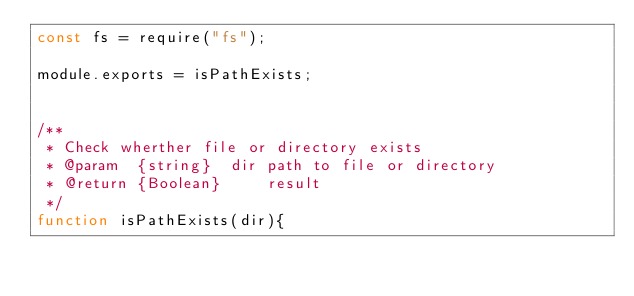Convert code to text. <code><loc_0><loc_0><loc_500><loc_500><_JavaScript_>const fs = require("fs");

module.exports = isPathExists;


/**
 * Check wherther file or directory exists
 * @param  {string}  dir path to file or directory
 * @return {Boolean}     result
 */
function isPathExists(dir){</code> 